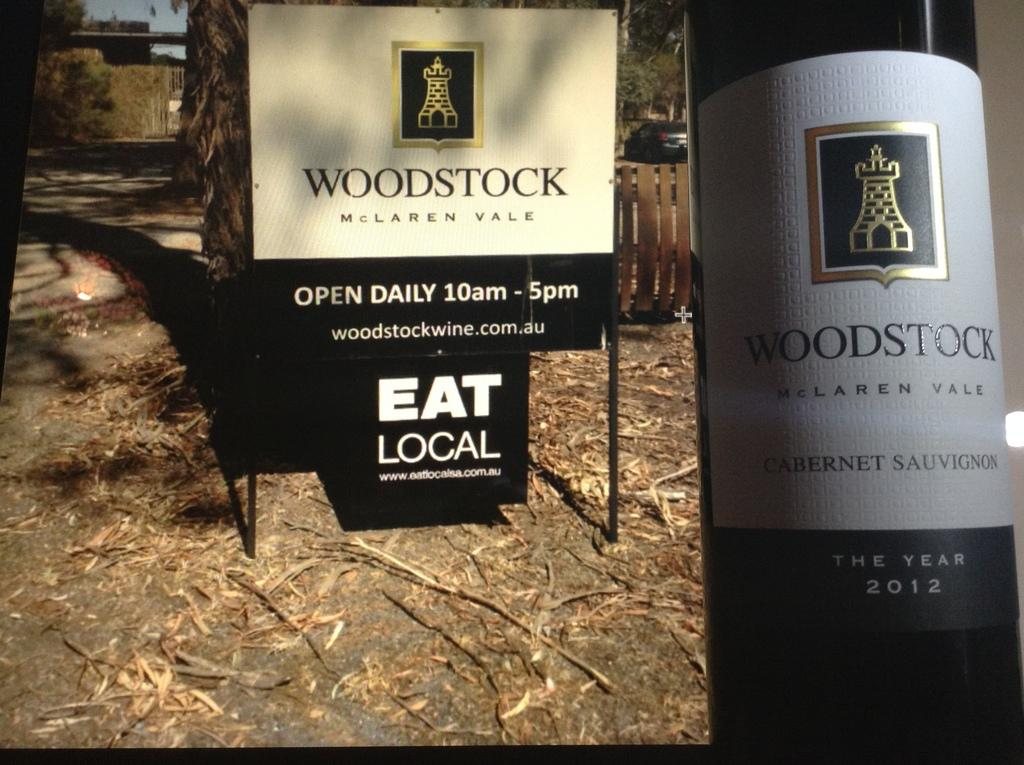<image>
Write a terse but informative summary of the picture. Bottle of Woodstock next to a black and white sign that says Woodstock. 